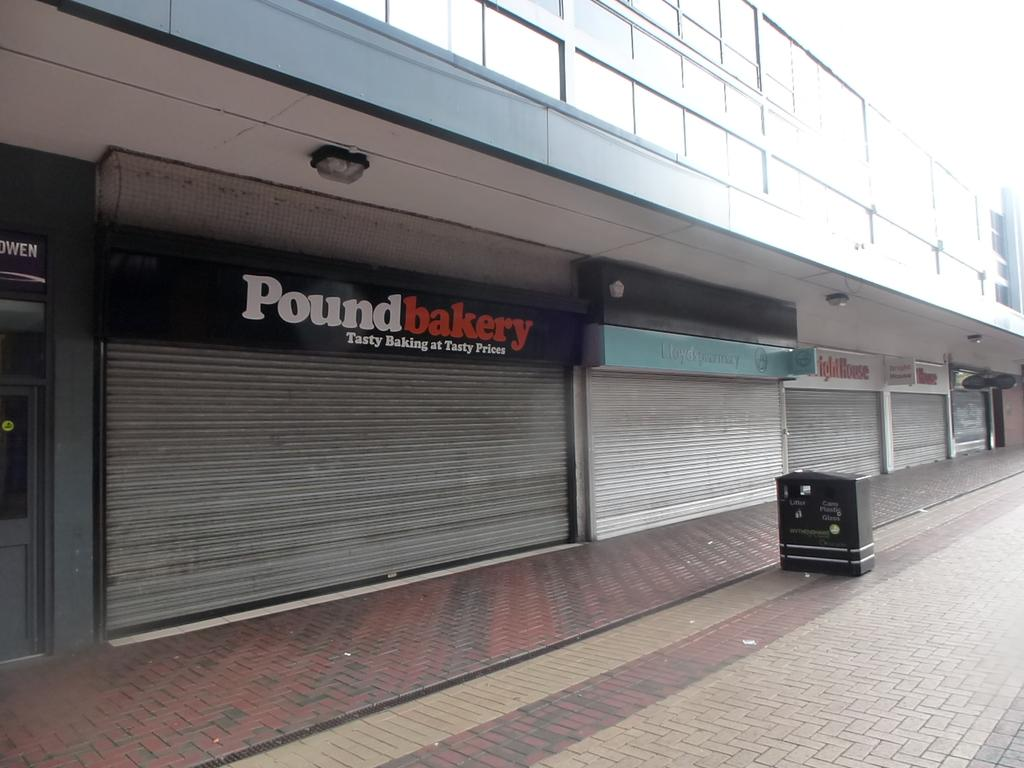<image>
Describe the image concisely. the outside of a building with a sign that says pound bakery 